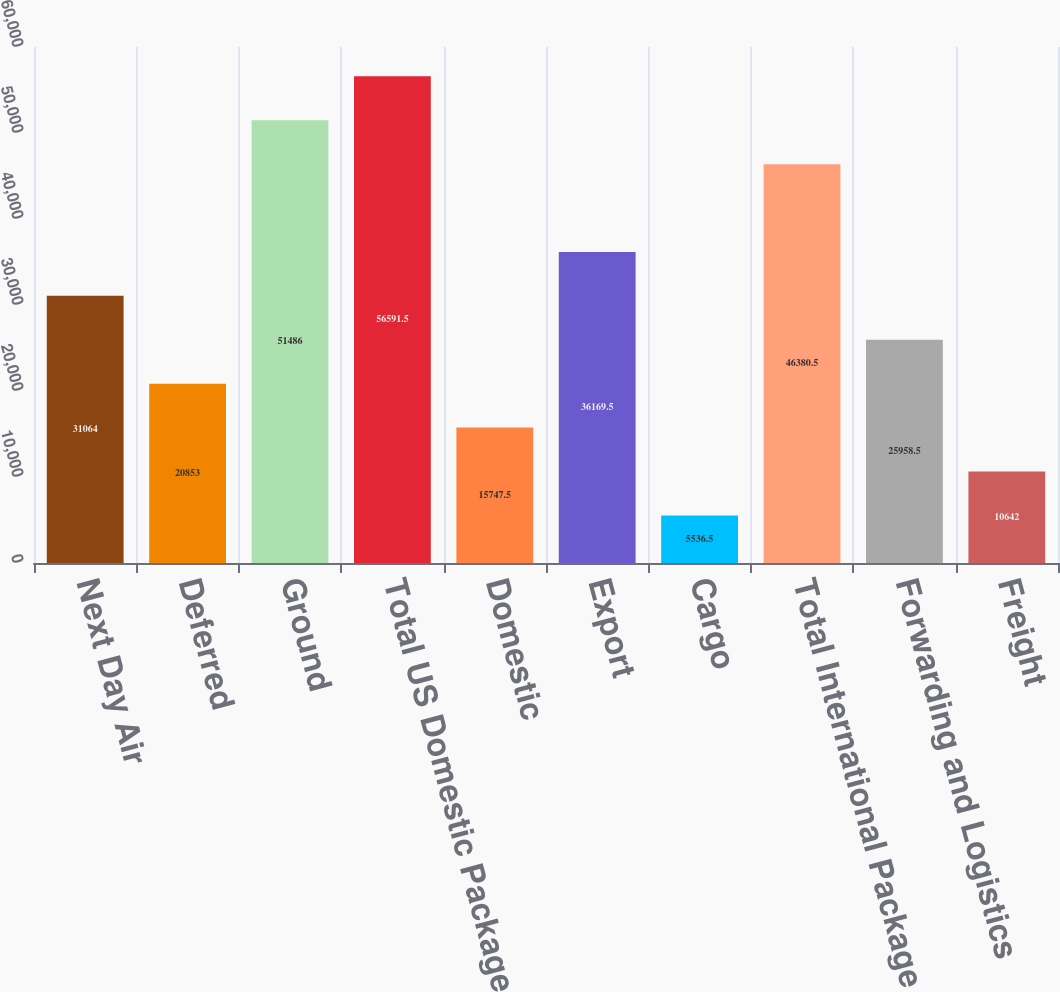Convert chart. <chart><loc_0><loc_0><loc_500><loc_500><bar_chart><fcel>Next Day Air<fcel>Deferred<fcel>Ground<fcel>Total US Domestic Package<fcel>Domestic<fcel>Export<fcel>Cargo<fcel>Total International Package<fcel>Forwarding and Logistics<fcel>Freight<nl><fcel>31064<fcel>20853<fcel>51486<fcel>56591.5<fcel>15747.5<fcel>36169.5<fcel>5536.5<fcel>46380.5<fcel>25958.5<fcel>10642<nl></chart> 